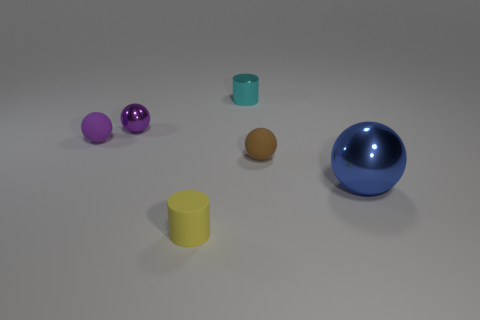What number of rubber balls are the same size as the cyan shiny object?
Your response must be concise. 2. What is the material of the small brown object that is the same shape as the large blue shiny thing?
Your response must be concise. Rubber. Is the color of the tiny shiny object that is behind the small purple shiny sphere the same as the matte sphere that is to the left of the cyan thing?
Keep it short and to the point. No. There is a rubber object that is on the left side of the tiny purple shiny object; what is its shape?
Ensure brevity in your answer.  Sphere. The large sphere is what color?
Your response must be concise. Blue. What shape is the small yellow thing that is made of the same material as the brown sphere?
Keep it short and to the point. Cylinder. There is a shiny sphere on the right side of the cyan cylinder; is its size the same as the tiny purple matte object?
Your answer should be very brief. No. How many things are either tiny objects right of the tiny cyan metal cylinder or small cyan shiny things that are behind the tiny brown object?
Your response must be concise. 2. There is a matte ball that is left of the cyan shiny cylinder; is its color the same as the large shiny ball?
Your answer should be compact. No. What number of metallic things are small purple balls or tiny cylinders?
Provide a short and direct response. 2. 